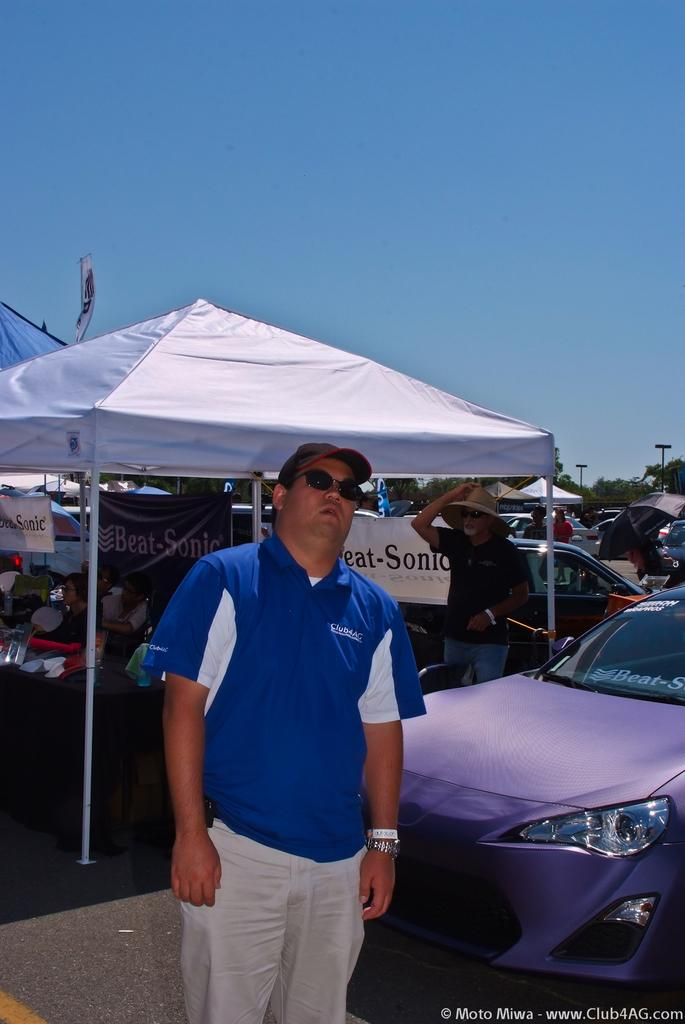What is the person in the image wearing? The person is wearing a blue and white colored dress. How would you describe the appearance of the person? The person is stunning. What can be seen in the background of the image? There are tents, people, vehicles, trees, and the sky visible in the background of the image. How many cats are present in the image? There are no cats present in the image. What is the result of adding the number of vehicles and tents in the image? The provided facts do not give specific numbers of vehicles or tents, so it is not possible to perform the addition. 